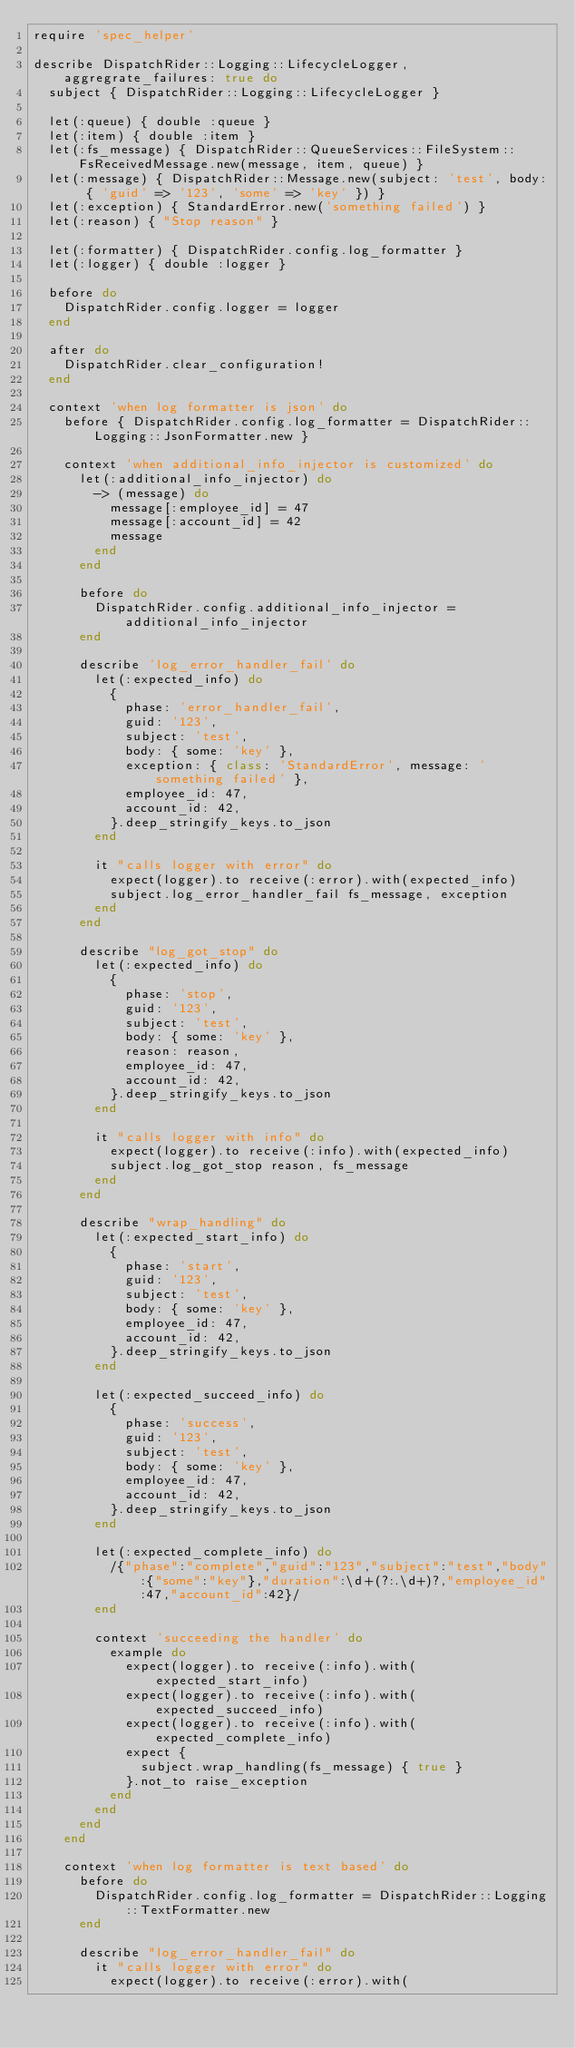<code> <loc_0><loc_0><loc_500><loc_500><_Ruby_>require 'spec_helper'

describe DispatchRider::Logging::LifecycleLogger, aggregrate_failures: true do
  subject { DispatchRider::Logging::LifecycleLogger }

  let(:queue) { double :queue }
  let(:item) { double :item }
  let(:fs_message) { DispatchRider::QueueServices::FileSystem::FsReceivedMessage.new(message, item, queue) }
  let(:message) { DispatchRider::Message.new(subject: 'test', body: { 'guid' => '123', 'some' => 'key' }) }
  let(:exception) { StandardError.new('something failed') }
  let(:reason) { "Stop reason" }

  let(:formatter) { DispatchRider.config.log_formatter }
  let(:logger) { double :logger }

  before do
    DispatchRider.config.logger = logger
  end

  after do
    DispatchRider.clear_configuration!
  end

  context 'when log formatter is json' do
    before { DispatchRider.config.log_formatter = DispatchRider::Logging::JsonFormatter.new }

    context 'when additional_info_injector is customized' do
      let(:additional_info_injector) do
        -> (message) do
          message[:employee_id] = 47
          message[:account_id] = 42
          message
        end
      end

      before do
        DispatchRider.config.additional_info_injector = additional_info_injector
      end

      describe 'log_error_handler_fail' do
        let(:expected_info) do
          {
            phase: 'error_handler_fail',
            guid: '123',
            subject: 'test',
            body: { some: 'key' },
            exception: { class: 'StandardError', message: 'something failed' },
            employee_id: 47,
            account_id: 42,
          }.deep_stringify_keys.to_json
        end

        it "calls logger with error" do
          expect(logger).to receive(:error).with(expected_info)
          subject.log_error_handler_fail fs_message, exception
        end
      end

      describe "log_got_stop" do
        let(:expected_info) do
          {
            phase: 'stop',
            guid: '123',
            subject: 'test',
            body: { some: 'key' },
            reason: reason,
            employee_id: 47,
            account_id: 42,
          }.deep_stringify_keys.to_json
        end

        it "calls logger with info" do
          expect(logger).to receive(:info).with(expected_info)
          subject.log_got_stop reason, fs_message
        end
      end

      describe "wrap_handling" do
        let(:expected_start_info) do
          {
            phase: 'start',
            guid: '123',
            subject: 'test',
            body: { some: 'key' },
            employee_id: 47,
            account_id: 42,
          }.deep_stringify_keys.to_json
        end

        let(:expected_succeed_info) do
          {
            phase: 'success',
            guid: '123',
            subject: 'test',
            body: { some: 'key' },
            employee_id: 47,
            account_id: 42,
          }.deep_stringify_keys.to_json
        end

        let(:expected_complete_info) do
          /{"phase":"complete","guid":"123","subject":"test","body":{"some":"key"},"duration":\d+(?:.\d+)?,"employee_id":47,"account_id":42}/
        end

        context 'succeeding the handler' do
          example do
            expect(logger).to receive(:info).with(expected_start_info)
            expect(logger).to receive(:info).with(expected_succeed_info)
            expect(logger).to receive(:info).with(expected_complete_info)
            expect {
              subject.wrap_handling(fs_message) { true }
            }.not_to raise_exception
          end
        end
      end
    end

    context 'when log formatter is text based' do
      before do
        DispatchRider.config.log_formatter = DispatchRider::Logging::TextFormatter.new
      end

      describe "log_error_handler_fail" do
        it "calls logger with error" do
          expect(logger).to receive(:error).with(</code> 